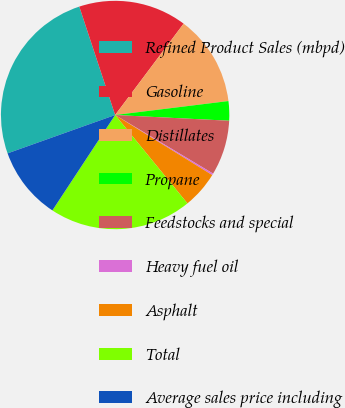Convert chart to OTSL. <chart><loc_0><loc_0><loc_500><loc_500><pie_chart><fcel>Refined Product Sales (mbpd)<fcel>Gasoline<fcel>Distillates<fcel>Propane<fcel>Feedstocks and special<fcel>Heavy fuel oil<fcel>Asphalt<fcel>Total<fcel>Average sales price including<nl><fcel>25.37%<fcel>15.32%<fcel>12.81%<fcel>2.75%<fcel>7.78%<fcel>0.24%<fcel>5.27%<fcel>20.17%<fcel>10.29%<nl></chart> 